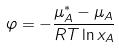Convert formula to latex. <formula><loc_0><loc_0><loc_500><loc_500>\varphi = - \frac { \mu _ { A } ^ { * } - \mu _ { A } } { R T \ln x _ { A } }</formula> 